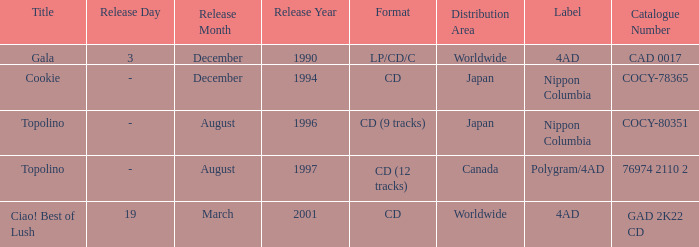When was Gala released? Worldwide. Could you help me parse every detail presented in this table? {'header': ['Title', 'Release Day', 'Release Month', 'Release Year', 'Format', 'Distribution Area', 'Label', 'Catalogue Number'], 'rows': [['Gala', '3', 'December', '1990', 'LP/CD/C', 'Worldwide', '4AD', 'CAD 0017'], ['Cookie', '-', 'December', '1994', 'CD', 'Japan', 'Nippon Columbia', 'COCY-78365'], ['Topolino', '-', 'August', '1996', 'CD (9 tracks)', 'Japan', 'Nippon Columbia', 'COCY-80351'], ['Topolino', '-', 'August', '1997', 'CD (12 tracks)', 'Canada', 'Polygram/4AD', '76974 2110 2'], ['Ciao! Best of Lush', '19', 'March', '2001', 'CD', 'Worldwide', '4AD', 'GAD 2K22 CD']]} 